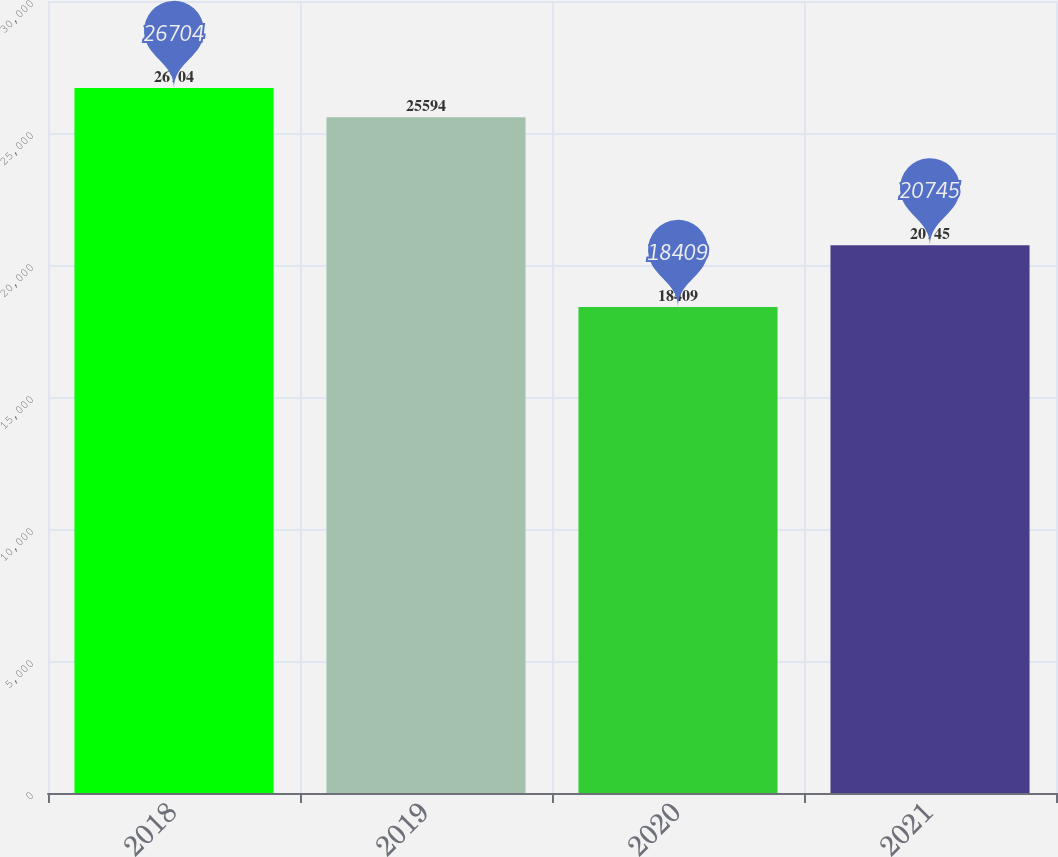Convert chart to OTSL. <chart><loc_0><loc_0><loc_500><loc_500><bar_chart><fcel>2018<fcel>2019<fcel>2020<fcel>2021<nl><fcel>26704<fcel>25594<fcel>18409<fcel>20745<nl></chart> 